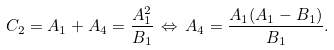<formula> <loc_0><loc_0><loc_500><loc_500>C _ { 2 } = A _ { 1 } + A _ { 4 } = \frac { A _ { 1 } ^ { 2 } } { B _ { 1 } } \, \Leftrightarrow \, A _ { 4 } = \frac { A _ { 1 } ( A _ { 1 } - B _ { 1 } ) } { B _ { 1 } } .</formula> 